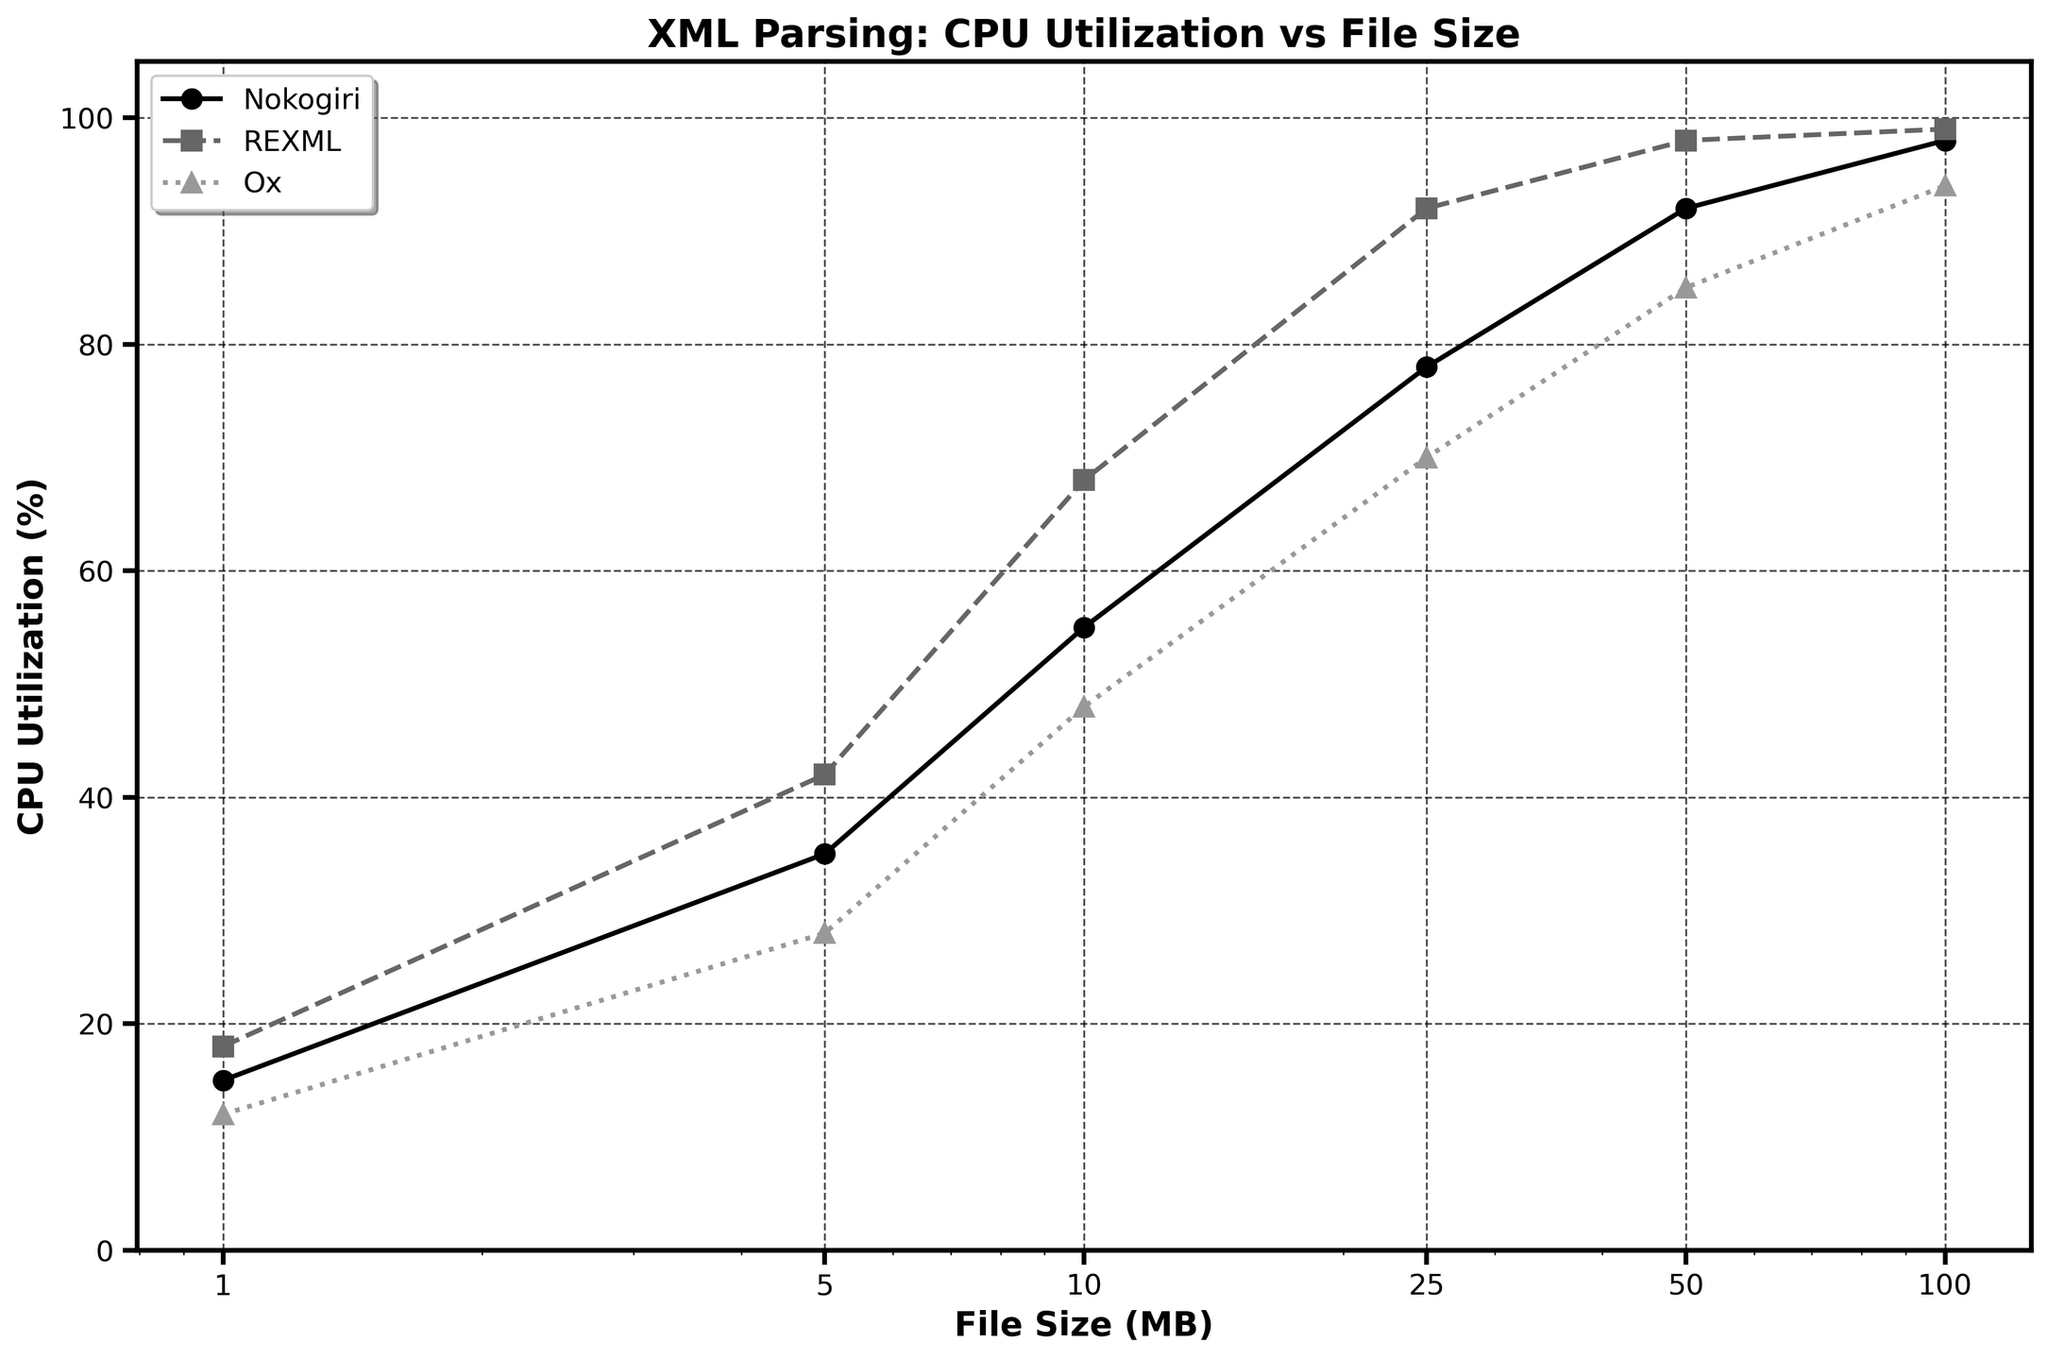What is the title of the figure? The title of the figure is displayed at the top and typically summarizes the figure's content. It reads "XML Parsing: CPU Utilization vs File Size".
Answer: XML Parsing: CPU Utilization vs File Size Which parsing library has the highest CPU utilization for a 50 MB file? Look at the data points for the file size of 50 MB across different lines. The highest CPU utilization value corresponds to REXML, with a value of 98%.
Answer: REXML What are the x-axis and y-axis labels? The labels for the axes are typically displayed near the axes themselves. The x-axis is labeled "File Size (MB)" and the y-axis is labeled "CPU Utilization (%)".
Answer: File Size (MB) and CPU Utilization (%) How does the CPU utilization of Nokogiri change as the file size increases from 1 MB to 100 MB? Trace the line associated with Nokogiri across the x-axis from 1 MB to 100 MB. CPU Utilization increases from 15% at 1 MB to 98% at 100 MB.
Answer: Increases from 15% to 98% Which parsing library consistently uses the least CPU across all file sizes? Compare the lines for all three parsers across all file sizes. The line representing Ox is consistently lower than that for Nokogiri and REXML.
Answer: Ox At what file size does REXML reach near 100% CPU utilization? Look for the point at which the line for REXML approaches 100% on the y-axis. This occurs at 100 MB.
Answer: 100 MB How much more CPU does REXML use compared to Ox for a 10 MB file? For 10 MB, read the CPU utilization values of REXML (68%) and Ox (48%). The difference is 68% - 48%.
Answer: 20% What is the average CPU utilization of Nokogiri across all file sizes? Sum the CPU utilizations for Nokogiri (15 + 35 + 55 + 78 + 92 + 98) and divide by the number of file size points (6). The average is (15 + 35 + 55 + 78 + 92 + 98) / 6 = 62.17%.
Answer: 62.17% Which parsing library shows the most linear increase in CPU utilization as the file size increases? Observe the trend of each parsing library as file size increases. The Ox line appears to show a more linear increase compared to Nokogiri and REXML.
Answer: Ox What is the CPU utilization for parsing a 5 MB file using Nokogiri? Locate the data point for Nokogiri at the 5 MB mark on the x-axis. It shows a CPU utilization of 35%.
Answer: 35% 